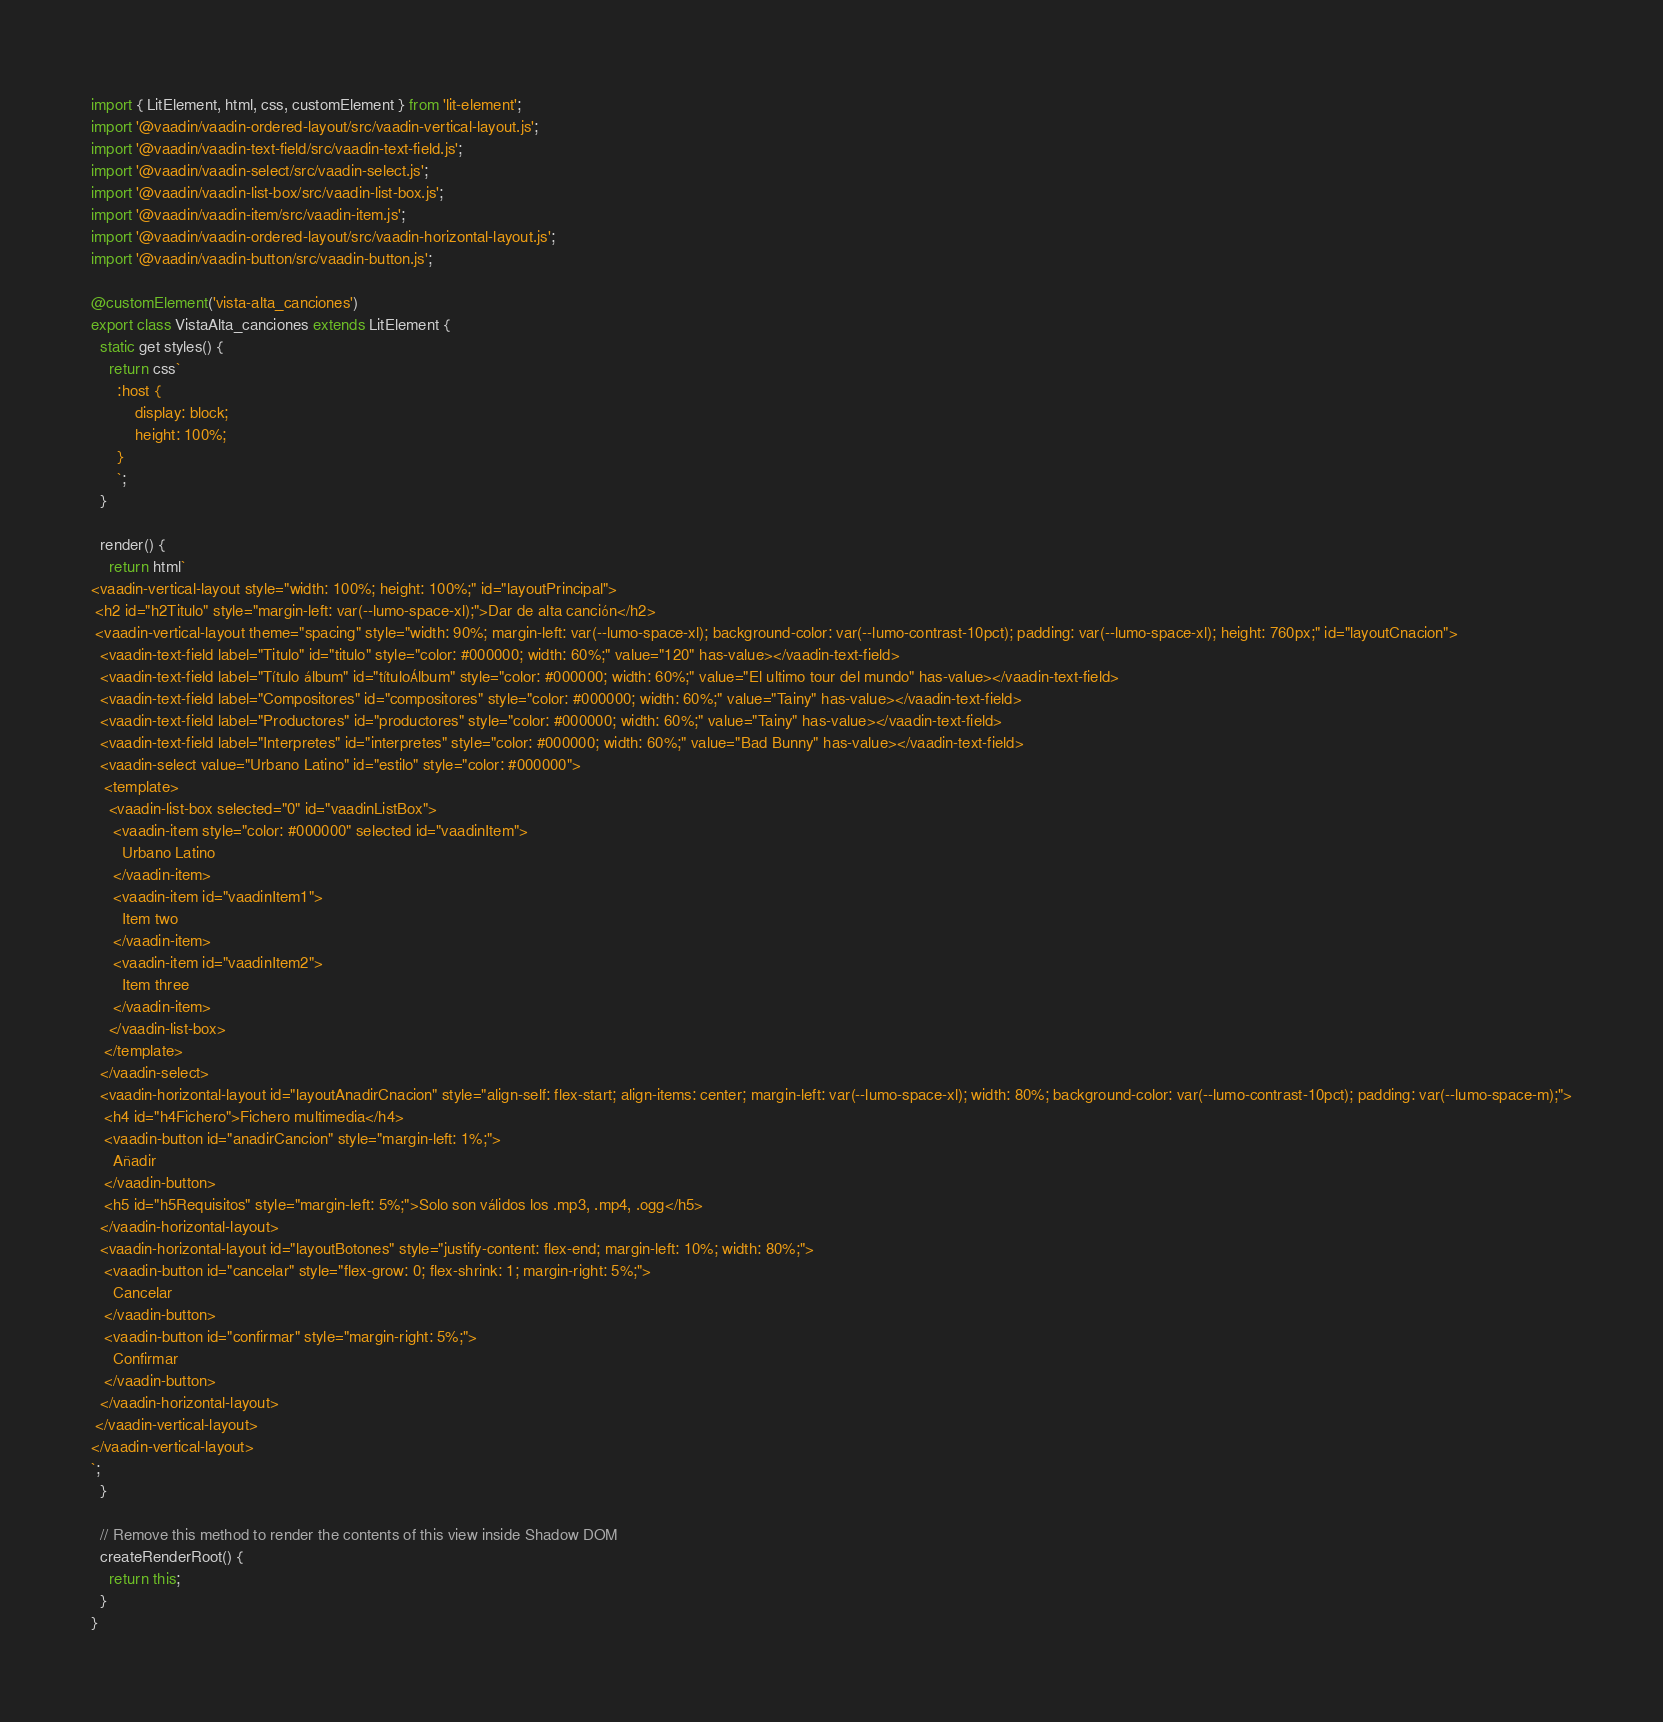Convert code to text. <code><loc_0><loc_0><loc_500><loc_500><_TypeScript_>import { LitElement, html, css, customElement } from 'lit-element';
import '@vaadin/vaadin-ordered-layout/src/vaadin-vertical-layout.js';
import '@vaadin/vaadin-text-field/src/vaadin-text-field.js';
import '@vaadin/vaadin-select/src/vaadin-select.js';
import '@vaadin/vaadin-list-box/src/vaadin-list-box.js';
import '@vaadin/vaadin-item/src/vaadin-item.js';
import '@vaadin/vaadin-ordered-layout/src/vaadin-horizontal-layout.js';
import '@vaadin/vaadin-button/src/vaadin-button.js';

@customElement('vista-alta_canciones')
export class VistaAlta_canciones extends LitElement {
  static get styles() {
    return css`
      :host {
          display: block;
          height: 100%;
      }
      `;
  }

  render() {
    return html`
<vaadin-vertical-layout style="width: 100%; height: 100%;" id="layoutPrincipal">
 <h2 id="h2Titulo" style="margin-left: var(--lumo-space-xl);">Dar de alta canción</h2>
 <vaadin-vertical-layout theme="spacing" style="width: 90%; margin-left: var(--lumo-space-xl); background-color: var(--lumo-contrast-10pct); padding: var(--lumo-space-xl); height: 760px;" id="layoutCnacion">
  <vaadin-text-field label="Titulo" id="titulo" style="color: #000000; width: 60%;" value="120" has-value></vaadin-text-field>
  <vaadin-text-field label="Título álbum" id="títuloÁlbum" style="color: #000000; width: 60%;" value="El ultimo tour del mundo" has-value></vaadin-text-field>
  <vaadin-text-field label="Compositores" id="compositores" style="color: #000000; width: 60%;" value="Tainy" has-value></vaadin-text-field>
  <vaadin-text-field label="Productores" id="productores" style="color: #000000; width: 60%;" value="Tainy" has-value></vaadin-text-field>
  <vaadin-text-field label="Interpretes" id="interpretes" style="color: #000000; width: 60%;" value="Bad Bunny" has-value></vaadin-text-field>
  <vaadin-select value="Urbano Latino" id="estilo" style="color: #000000">
   <template>
    <vaadin-list-box selected="0" id="vaadinListBox">
     <vaadin-item style="color: #000000" selected id="vaadinItem">
       Urbano Latino 
     </vaadin-item>
     <vaadin-item id="vaadinItem1">
       Item two 
     </vaadin-item>
     <vaadin-item id="vaadinItem2">
       Item three 
     </vaadin-item>
    </vaadin-list-box>
   </template>
  </vaadin-select>
  <vaadin-horizontal-layout id="layoutAnadirCnacion" style="align-self: flex-start; align-items: center; margin-left: var(--lumo-space-xl); width: 80%; background-color: var(--lumo-contrast-10pct); padding: var(--lumo-space-m);">
   <h4 id="h4Fichero">Fichero multimedia</h4>
   <vaadin-button id="anadirCancion" style="margin-left: 1%;">
     Añadir 
   </vaadin-button>
   <h5 id="h5Requisitos" style="margin-left: 5%;">Solo son válidos los .mp3, .mp4, .ogg</h5>
  </vaadin-horizontal-layout>
  <vaadin-horizontal-layout id="layoutBotones" style="justify-content: flex-end; margin-left: 10%; width: 80%;">
   <vaadin-button id="cancelar" style="flex-grow: 0; flex-shrink: 1; margin-right: 5%;">
     Cancelar 
   </vaadin-button>
   <vaadin-button id="confirmar" style="margin-right: 5%;">
     Confirmar 
   </vaadin-button>
  </vaadin-horizontal-layout>
 </vaadin-vertical-layout>
</vaadin-vertical-layout>
`;
  }

  // Remove this method to render the contents of this view inside Shadow DOM
  createRenderRoot() {
    return this;
  }
}
</code> 